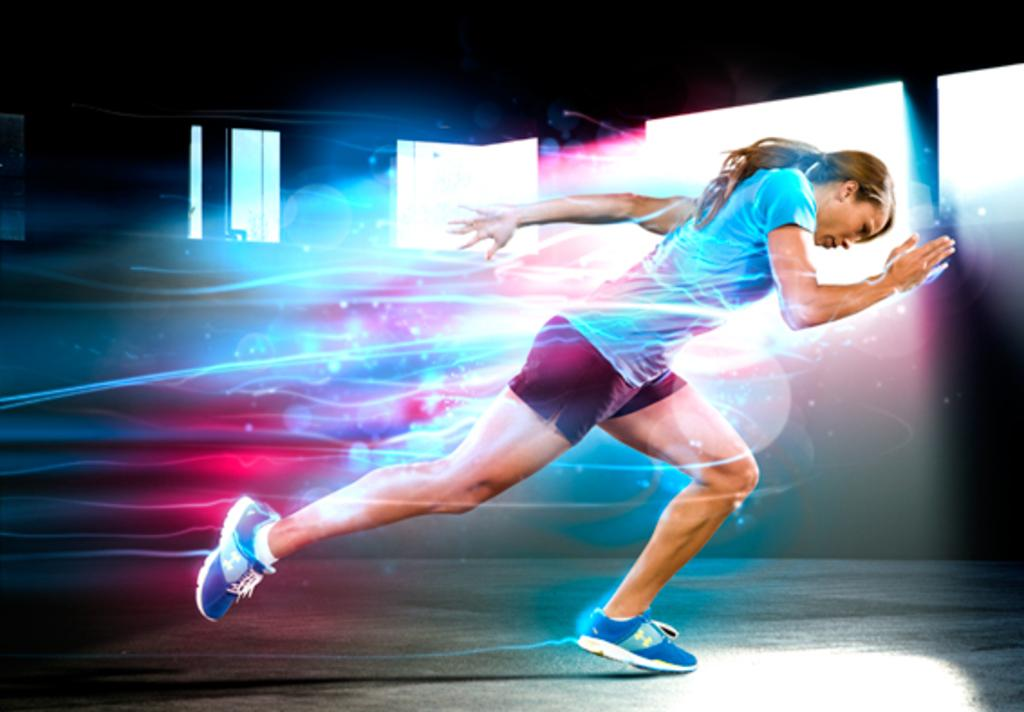What type of image is being described? The image is a graphical representation. Can you describe the main subject in the image? There is a woman in the image. What is the woman doing in the image? The woman is running. What color is the woman's t-shirt in the image? The woman is wearing a blue t-shirt. What color are the woman's shorts in the image? The woman is wearing black shorts. What type of cheese is being protested against in the image? There is no cheese or protest present in the image; it features a woman running while wearing a blue t-shirt and black shorts. 